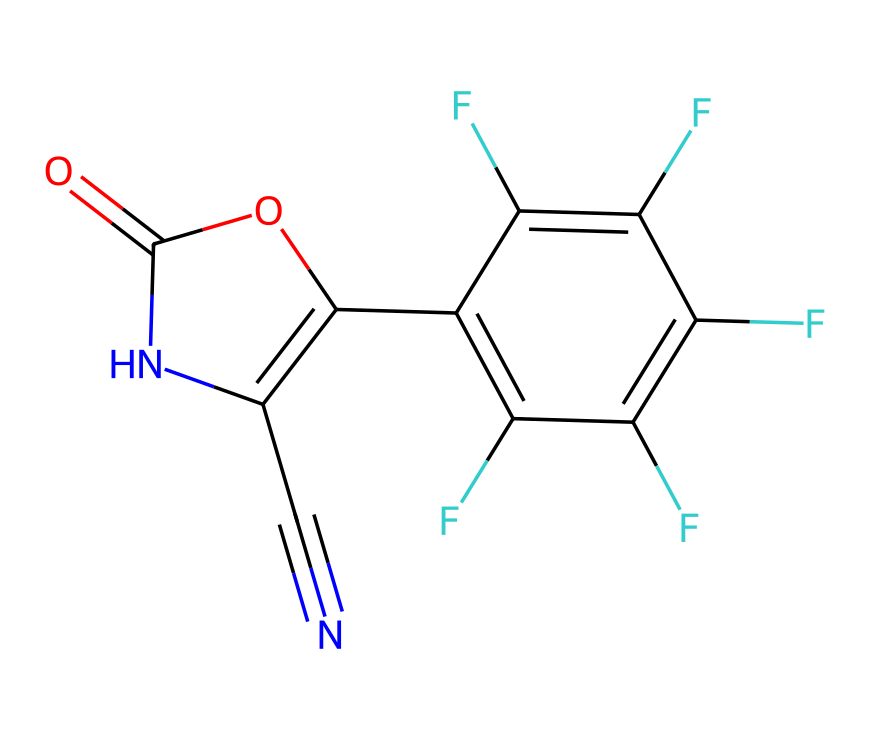What is the molecular formula of fludioxonil? To determine the molecular formula, we need to count the number of carbon, hydrogen, nitrogen, and oxygen atoms in the SMILES. The structure has 16 carbon atoms, 11 fluorine atoms, 2 nitrogen atoms, and 2 oxygen atoms. Thus, we can combine these counts into the molecular formula.
Answer: C16H11F4N2O2 How many rings are in the structure of fludioxonil? By examining the structure, we can see that there is one ring formed by the nitrogen and carbon atoms of the phenylpyrrole moiety. Thus, we determine that there is one distinct ring present in the chemical structure.
Answer: 1 What type of functional groups are present in fludioxonil? The chemical structure contains a carbonyl group (C=O), a cyano group (C#N), and an aromatic ring structure. Identifying these specific groups helps classify the functional components.
Answer: carbonyl, cyano, aromatic How many fluorine atoms are present in fludioxonil? Reviewing the SMILES indicates that there are four fluorine atoms attached in the aromatic portion of the chemical structure, which is critical for its fungicidal activity and properties.
Answer: 4 What is the significance of the cyano group in fludioxonil? The cyano group (C#N) is known to enhance the antifungal efficacy of chemical compounds, contributing to fludioxonil's function as a fungicide. Its presence indicates potential reactivity and helps in the binding to target sites.
Answer: enhances efficacy What type of organism does fludioxonil primarily target? Fludioxonil is primarily used to target various fungi, specifically in agricultural settings for seed and crop protection. Understanding the specific pathogens is crucial for effective application in fungicide practices.
Answer: fungi 